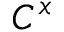<formula> <loc_0><loc_0><loc_500><loc_500>C ^ { x }</formula> 